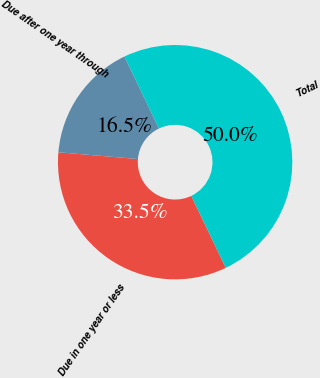Convert chart. <chart><loc_0><loc_0><loc_500><loc_500><pie_chart><fcel>Due in one year or less<fcel>Due after one year through<fcel>Total<nl><fcel>33.46%<fcel>16.54%<fcel>50.0%<nl></chart> 